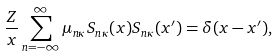Convert formula to latex. <formula><loc_0><loc_0><loc_500><loc_500>\frac { Z } { x } \sum _ { n = - \infty } ^ { \infty } \mu _ { n \kappa } S _ { n \kappa } ( x ) S _ { n \kappa } ( x ^ { \prime } ) = \delta ( x - x ^ { \prime } ) ,</formula> 